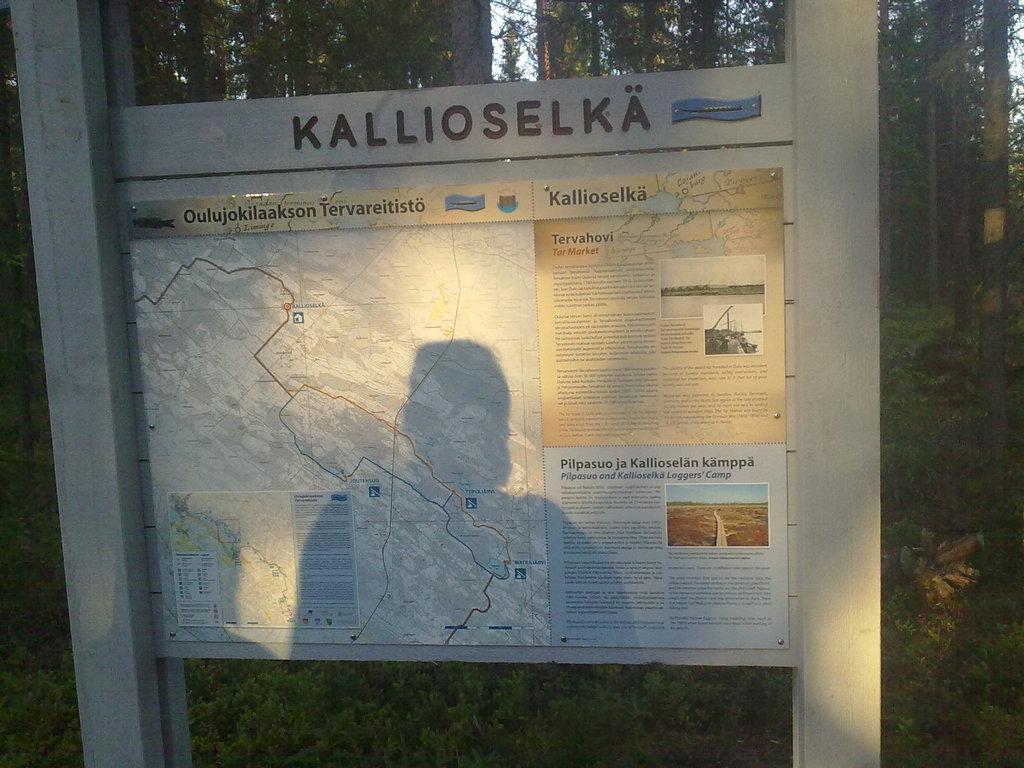Please provide a concise description of this image. In this image in front there is a board with some text and drawing on it. At the bottom of the image there is grass on the surface. In the background of the image there are trees and sky. 